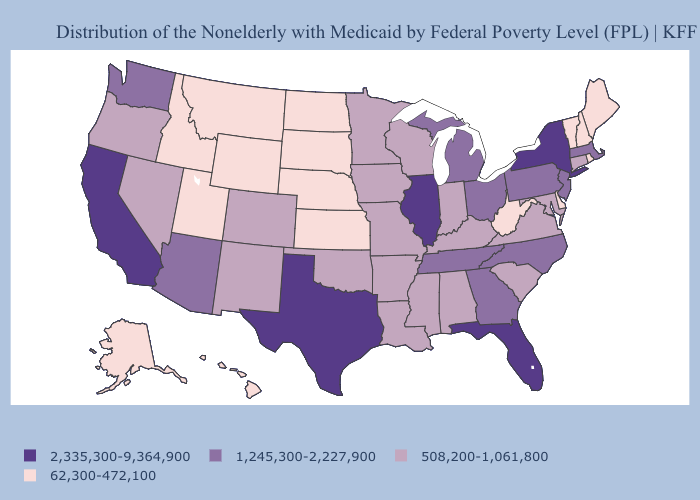What is the lowest value in states that border Montana?
Answer briefly. 62,300-472,100. Name the states that have a value in the range 1,245,300-2,227,900?
Short answer required. Arizona, Georgia, Massachusetts, Michigan, New Jersey, North Carolina, Ohio, Pennsylvania, Tennessee, Washington. Among the states that border New York , which have the lowest value?
Write a very short answer. Vermont. Which states hav the highest value in the West?
Quick response, please. California. What is the lowest value in the USA?
Quick response, please. 62,300-472,100. What is the value of Wyoming?
Give a very brief answer. 62,300-472,100. What is the value of Delaware?
Write a very short answer. 62,300-472,100. Among the states that border New Hampshire , does Vermont have the lowest value?
Quick response, please. Yes. Name the states that have a value in the range 508,200-1,061,800?
Quick response, please. Alabama, Arkansas, Colorado, Connecticut, Indiana, Iowa, Kentucky, Louisiana, Maryland, Minnesota, Mississippi, Missouri, Nevada, New Mexico, Oklahoma, Oregon, South Carolina, Virginia, Wisconsin. Name the states that have a value in the range 1,245,300-2,227,900?
Keep it brief. Arizona, Georgia, Massachusetts, Michigan, New Jersey, North Carolina, Ohio, Pennsylvania, Tennessee, Washington. What is the lowest value in states that border Wisconsin?
Be succinct. 508,200-1,061,800. Name the states that have a value in the range 62,300-472,100?
Be succinct. Alaska, Delaware, Hawaii, Idaho, Kansas, Maine, Montana, Nebraska, New Hampshire, North Dakota, Rhode Island, South Dakota, Utah, Vermont, West Virginia, Wyoming. Is the legend a continuous bar?
Answer briefly. No. Name the states that have a value in the range 62,300-472,100?
Give a very brief answer. Alaska, Delaware, Hawaii, Idaho, Kansas, Maine, Montana, Nebraska, New Hampshire, North Dakota, Rhode Island, South Dakota, Utah, Vermont, West Virginia, Wyoming. Is the legend a continuous bar?
Answer briefly. No. 